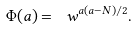<formula> <loc_0><loc_0><loc_500><loc_500>\Phi ( a ) = \ w ^ { a ( a - N ) / 2 } .</formula> 